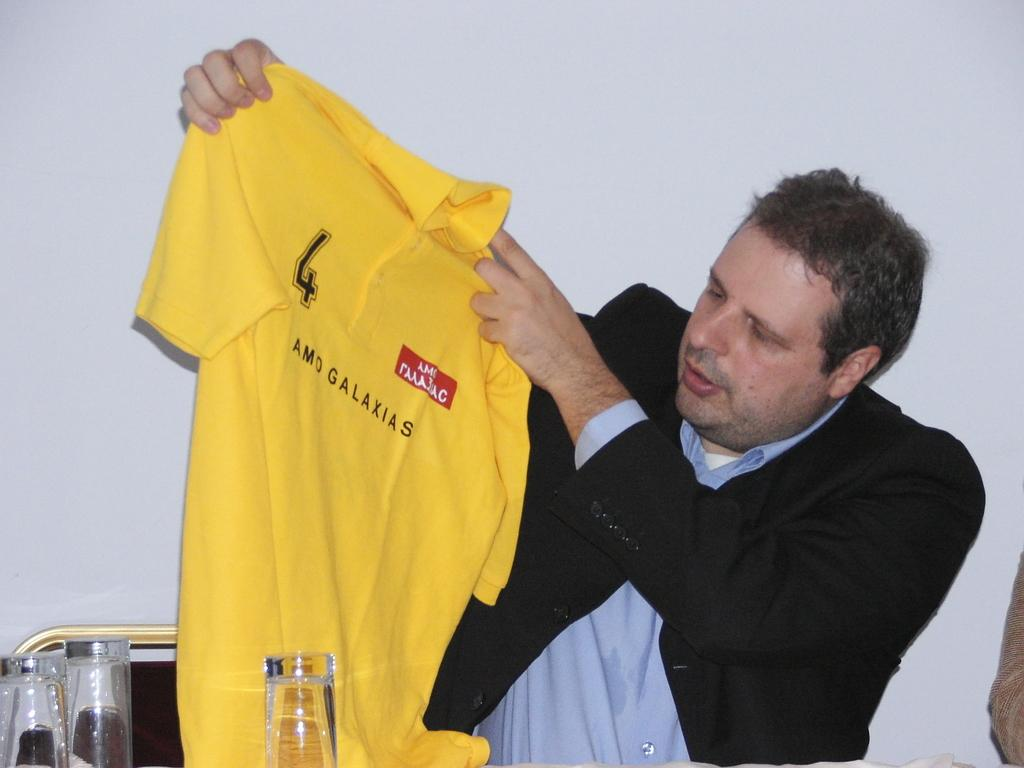Provide a one-sentence caption for the provided image. A man holding up a yellow shirt that reads AMO GALAXIAS. 